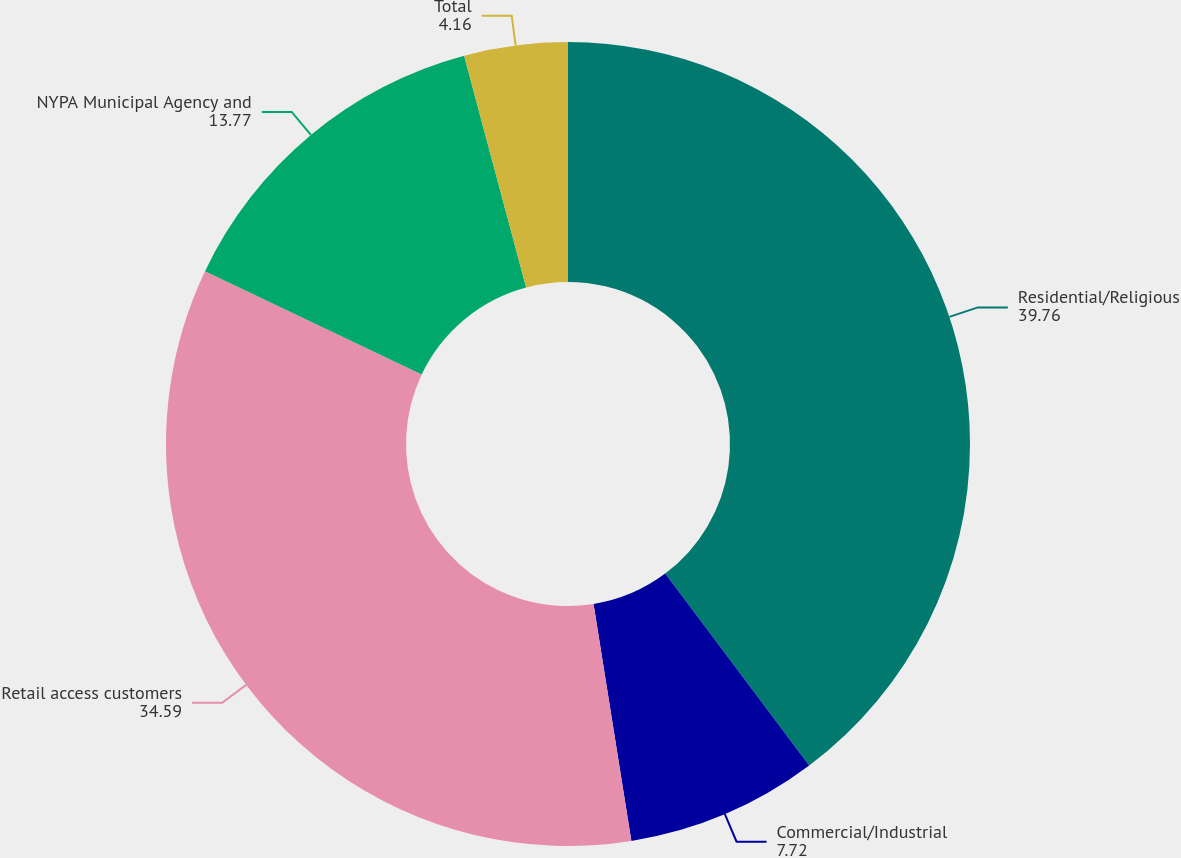<chart> <loc_0><loc_0><loc_500><loc_500><pie_chart><fcel>Residential/Religious<fcel>Commercial/Industrial<fcel>Retail access customers<fcel>NYPA Municipal Agency and<fcel>Total<nl><fcel>39.76%<fcel>7.72%<fcel>34.59%<fcel>13.77%<fcel>4.16%<nl></chart> 